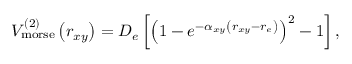<formula> <loc_0><loc_0><loc_500><loc_500>V _ { m o r s e } ^ { ( 2 ) } \left ( r _ { x y } \right ) = D _ { e } \left [ \left ( 1 - e ^ { - \alpha _ { x y } \left ( r _ { x y } - r _ { e } \right ) } \right ) ^ { 2 } - 1 \right ] ,</formula> 